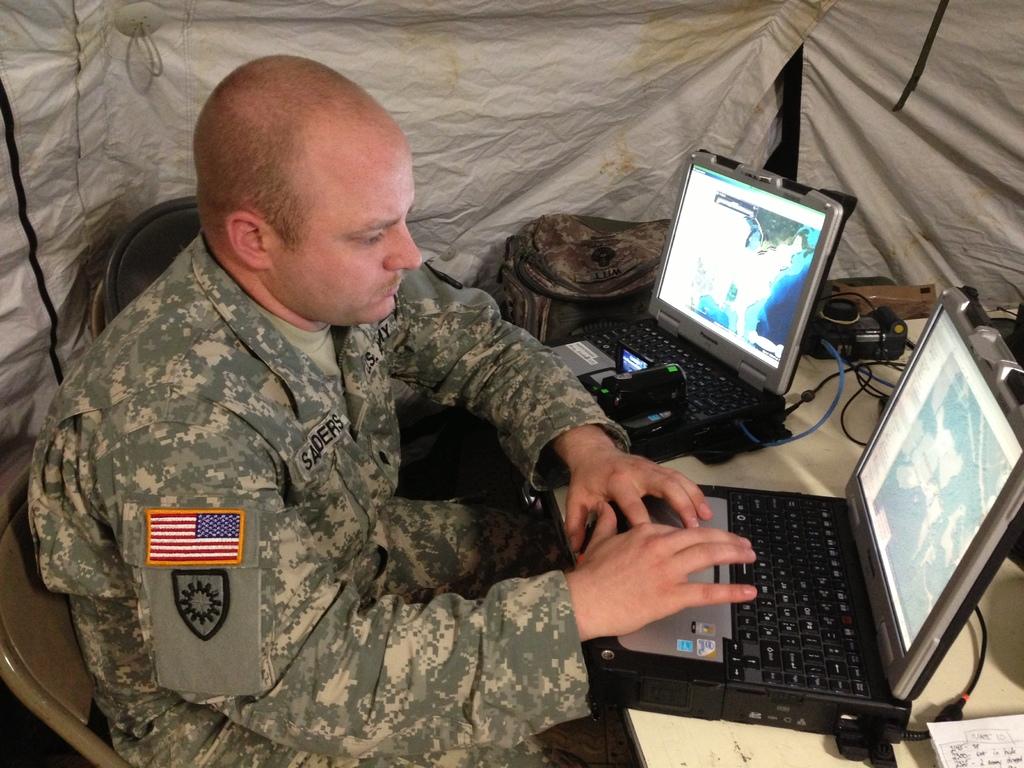How many screens are there?
Provide a succinct answer. Answering does not require reading text in the image. 